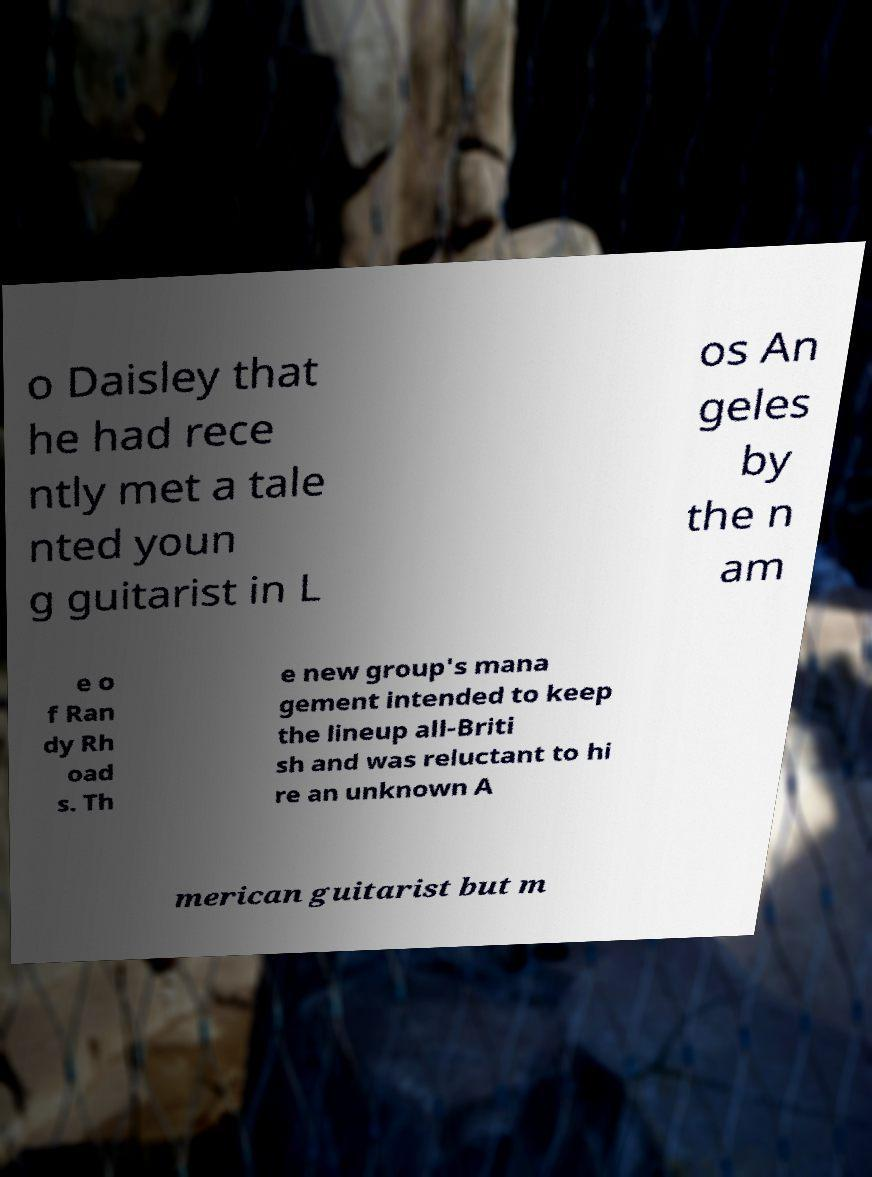Please read and relay the text visible in this image. What does it say? o Daisley that he had rece ntly met a tale nted youn g guitarist in L os An geles by the n am e o f Ran dy Rh oad s. Th e new group's mana gement intended to keep the lineup all-Briti sh and was reluctant to hi re an unknown A merican guitarist but m 